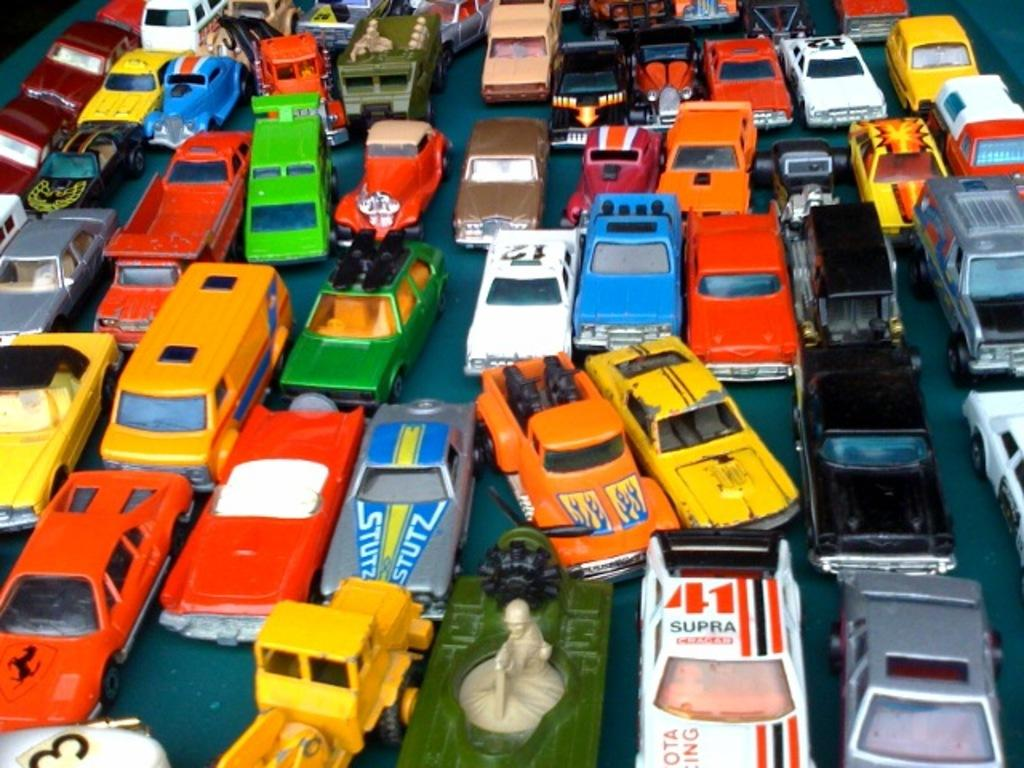<image>
Create a compact narrative representing the image presented. the number 41 is on the top of the car 